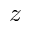Convert formula to latex. <formula><loc_0><loc_0><loc_500><loc_500>z</formula> 